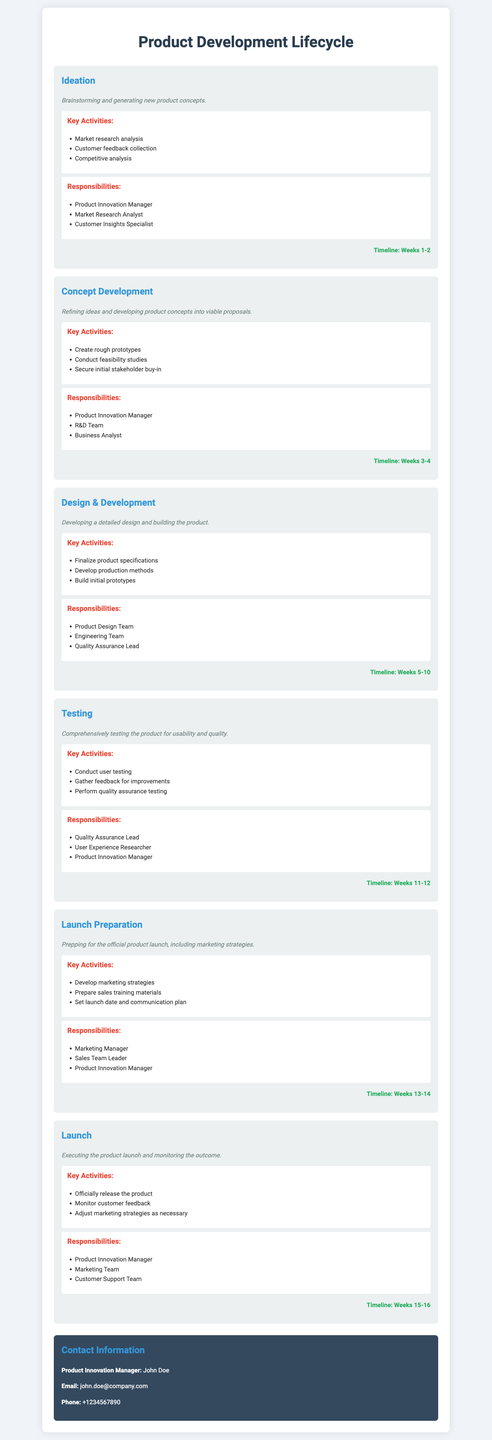what are the key activities in the Ideation phase? The key activities are listed under the Ideation phase, which includes market research analysis, customer feedback collection, and competitive analysis.
Answer: Market research analysis, customer feedback collection, competitive analysis who is responsible for the Testing phase? The responsibilities for the Testing phase identify the roles involved, which include the Quality Assurance Lead, User Experience Researcher, and Product Innovation Manager.
Answer: Quality Assurance Lead, User Experience Researcher, Product Innovation Manager how many weeks does the Design & Development phase last? The timeline provided indicates that the Design & Development phase lasts from Weeks 5 to 10.
Answer: 6 weeks what is the timeline for the Launch phase? The timeline section for the Launch phase specifies the duration from Weeks 15 to 16.
Answer: Weeks 15-16 which team creates rough prototypes during the Concept Development phase? The Responsibilities section for the Concept Development phase mentions that the R&D Team is responsible for creating rough prototypes.
Answer: R&D Team what marketing strategies are developed in the Launch Preparation phase? The Launch Preparation phase activities include developing marketing strategies, preparing sales training materials, and setting the launch date and communication plan.
Answer: Developing marketing strategies how many total phases are described in the document? The document outlines phases from ideation to launch, totaling six phases.
Answer: 6 phases who manages the overall product launch? The responsibilities in the Launch phase highlight that the Product Innovation Manager oversees the launch.
Answer: Product Innovation Manager 